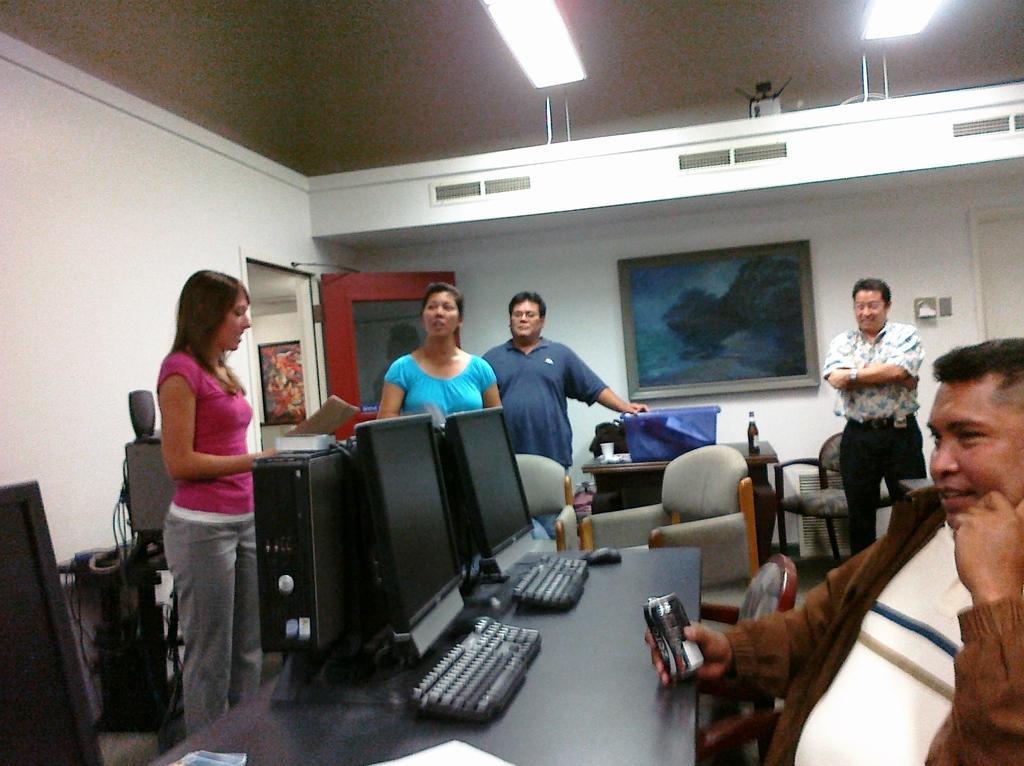Could you give a brief overview of what you see in this image? There are so many people standing in a room and one man sitting and holding a coke tin. Behind him there are so many monitors and keyboards on table. 